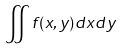<formula> <loc_0><loc_0><loc_500><loc_500>\iint f ( x , y ) d x d y</formula> 